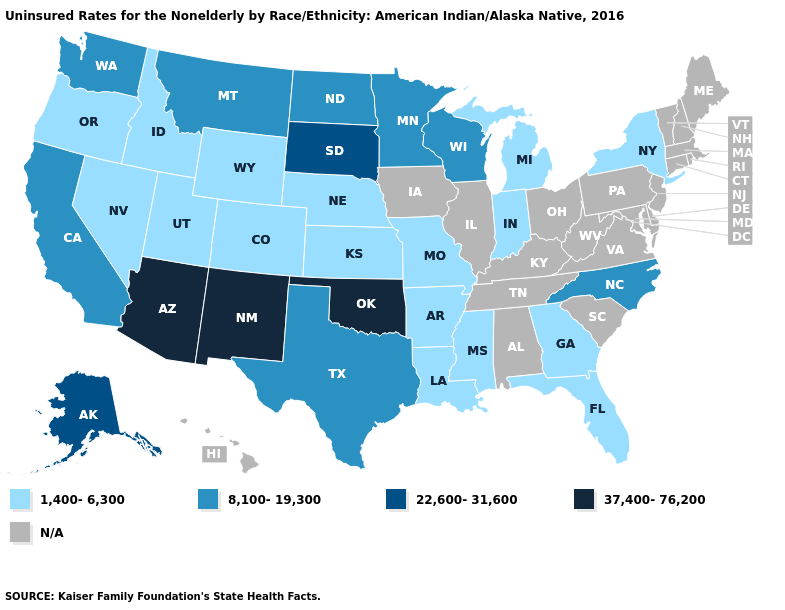Name the states that have a value in the range 1,400-6,300?
Quick response, please. Arkansas, Colorado, Florida, Georgia, Idaho, Indiana, Kansas, Louisiana, Michigan, Mississippi, Missouri, Nebraska, Nevada, New York, Oregon, Utah, Wyoming. Name the states that have a value in the range 1,400-6,300?
Concise answer only. Arkansas, Colorado, Florida, Georgia, Idaho, Indiana, Kansas, Louisiana, Michigan, Mississippi, Missouri, Nebraska, Nevada, New York, Oregon, Utah, Wyoming. What is the value of Oregon?
Answer briefly. 1,400-6,300. Does Nevada have the highest value in the West?
Quick response, please. No. Name the states that have a value in the range 8,100-19,300?
Short answer required. California, Minnesota, Montana, North Carolina, North Dakota, Texas, Washington, Wisconsin. Among the states that border Virginia , which have the highest value?
Concise answer only. North Carolina. What is the lowest value in the USA?
Short answer required. 1,400-6,300. Does Alaska have the lowest value in the West?
Concise answer only. No. What is the highest value in the West ?
Answer briefly. 37,400-76,200. Which states have the lowest value in the South?
Short answer required. Arkansas, Florida, Georgia, Louisiana, Mississippi. Does the first symbol in the legend represent the smallest category?
Answer briefly. Yes. What is the value of Rhode Island?
Give a very brief answer. N/A. Among the states that border Nevada , does Oregon have the highest value?
Keep it brief. No. What is the lowest value in states that border Nebraska?
Concise answer only. 1,400-6,300. 